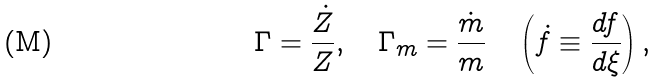Convert formula to latex. <formula><loc_0><loc_0><loc_500><loc_500>\Gamma = \frac { \dot { Z } } { Z } , \quad \Gamma _ { m } = \frac { \dot { m } } { m } \quad \left ( \dot { f } \equiv \frac { d f } { d \xi } \right ) ,</formula> 